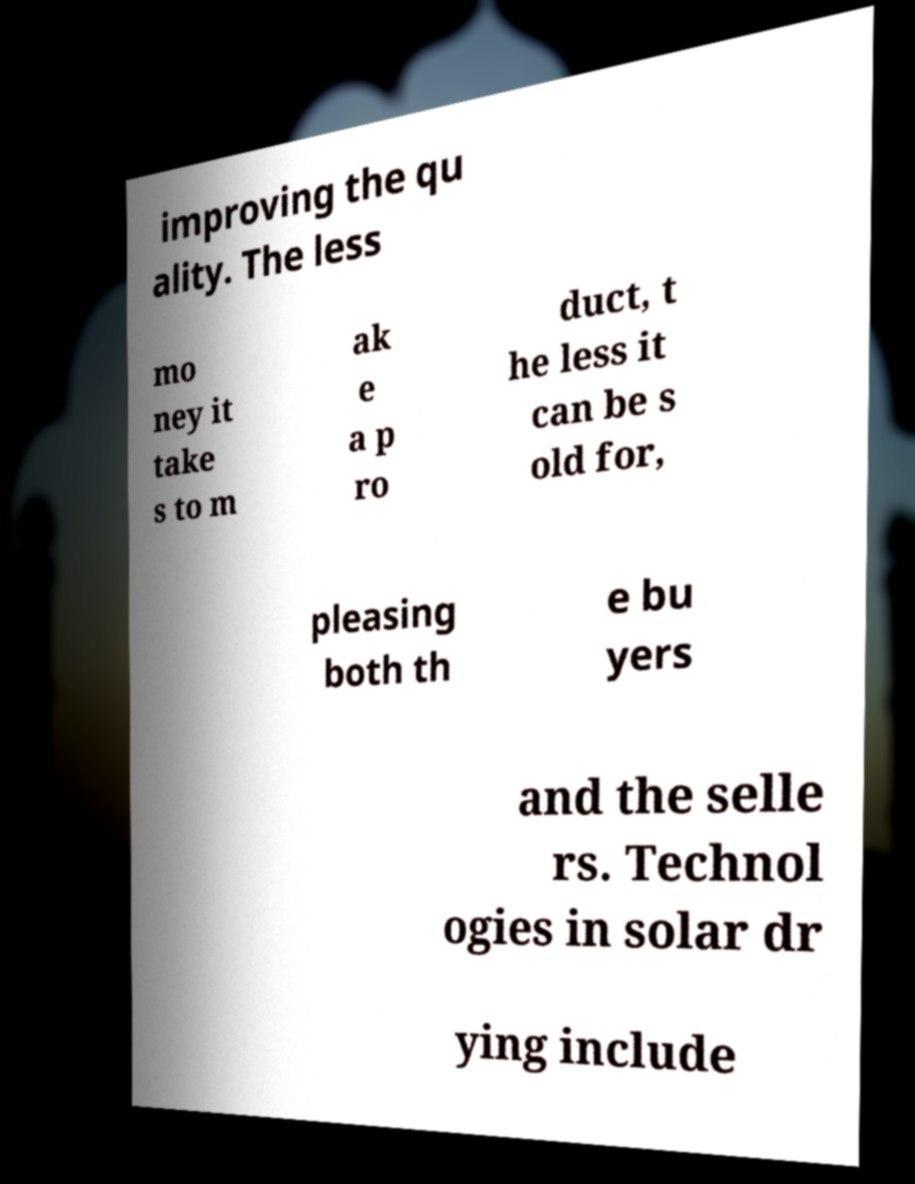For documentation purposes, I need the text within this image transcribed. Could you provide that? improving the qu ality. The less mo ney it take s to m ak e a p ro duct, t he less it can be s old for, pleasing both th e bu yers and the selle rs. Technol ogies in solar dr ying include 